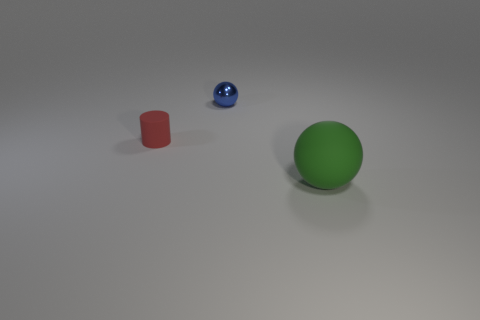What time of day does the lighting suggest in this scene? The scene seems to be lit with artificial lighting, given the soft shadows and the uniformity of light, suggesting an indoor setting without natural light, therefore it does not indicate a specific time of day. 